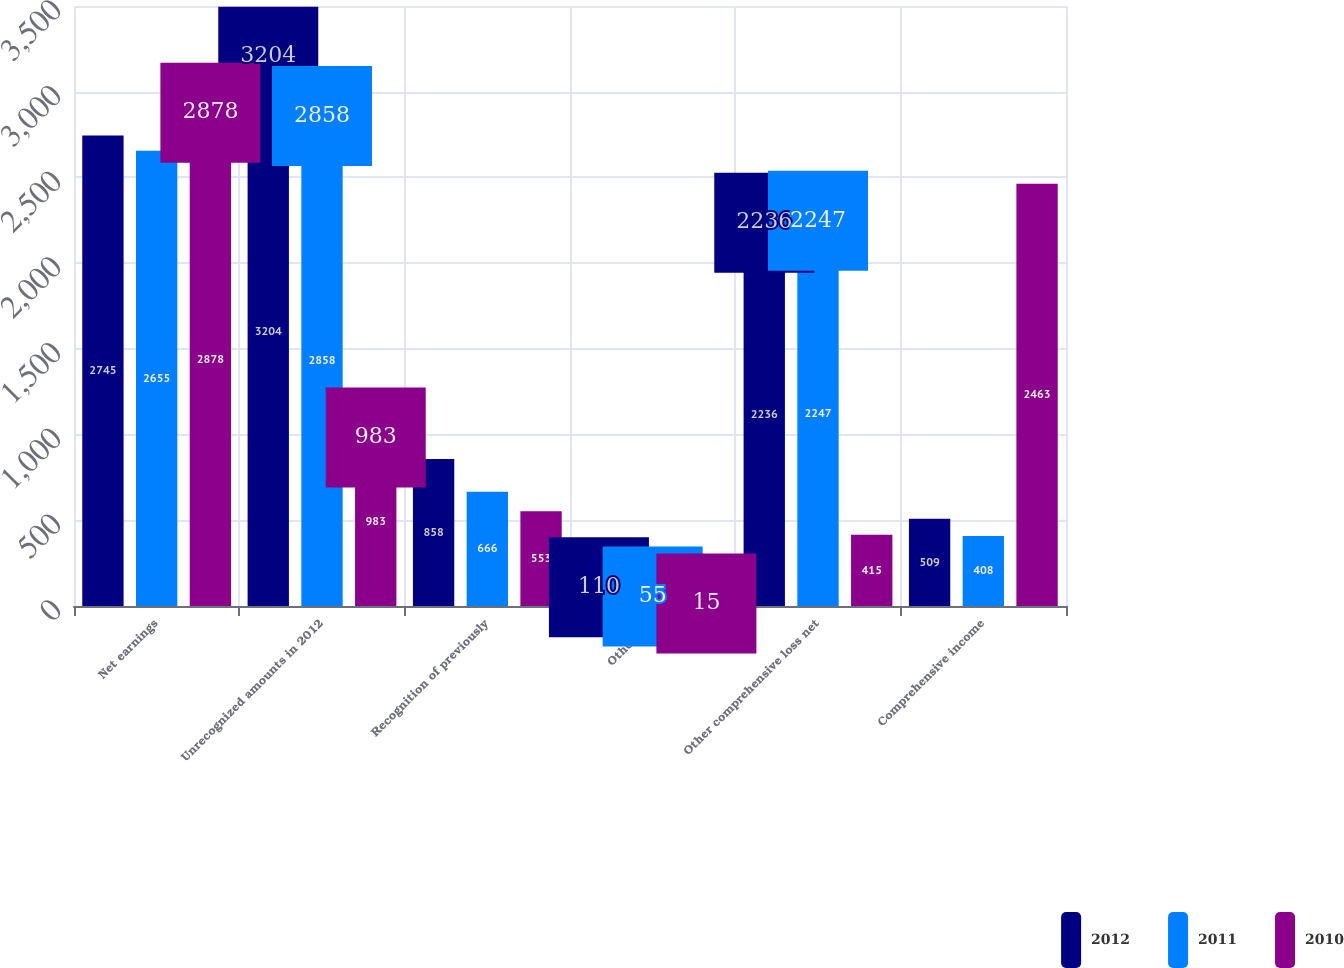<chart> <loc_0><loc_0><loc_500><loc_500><stacked_bar_chart><ecel><fcel>Net earnings<fcel>Unrecognized amounts in 2012<fcel>Recognition of previously<fcel>Other net<fcel>Other comprehensive loss net<fcel>Comprehensive income<nl><fcel>2012<fcel>2745<fcel>3204<fcel>858<fcel>110<fcel>2236<fcel>509<nl><fcel>2011<fcel>2655<fcel>2858<fcel>666<fcel>55<fcel>2247<fcel>408<nl><fcel>2010<fcel>2878<fcel>983<fcel>553<fcel>15<fcel>415<fcel>2463<nl></chart> 